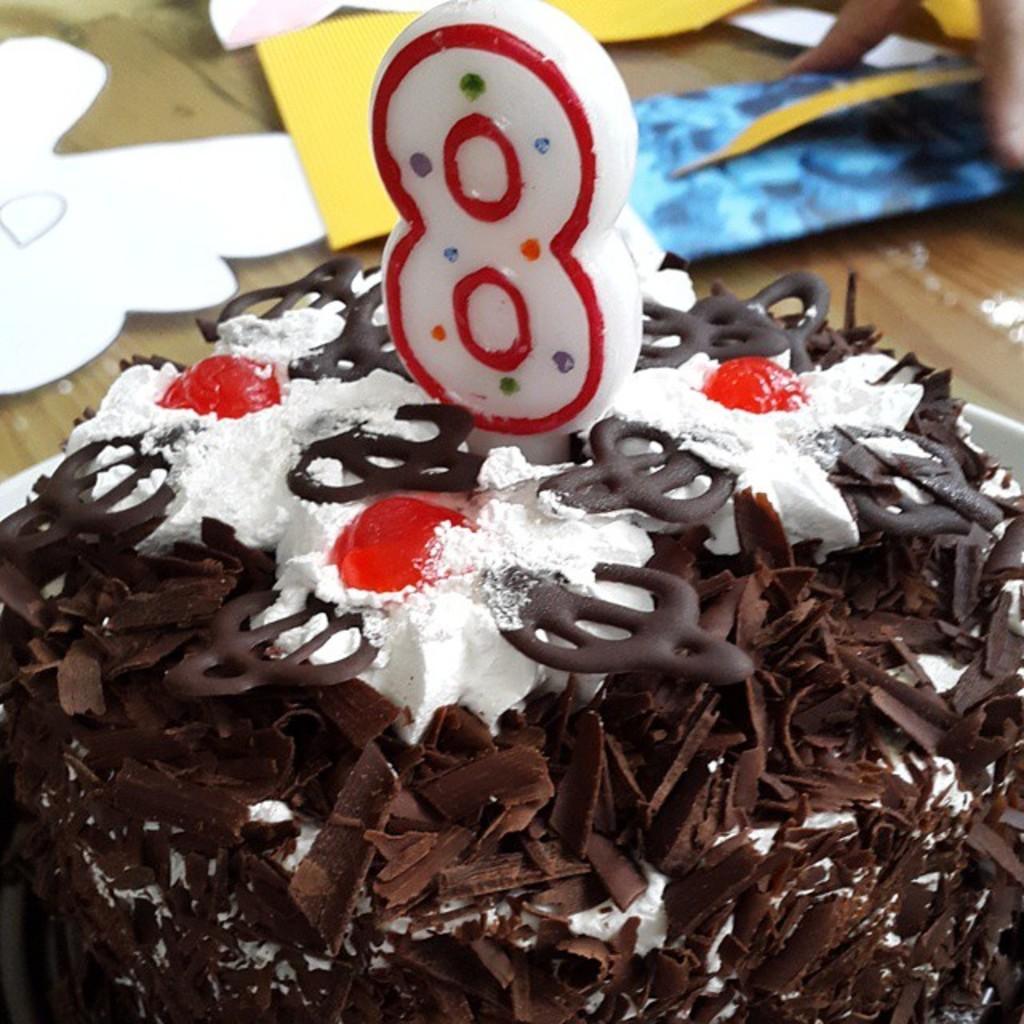In one or two sentences, can you explain what this image depicts? In this image we can see a cake on the table. In the background of the image there is a person's hand. 